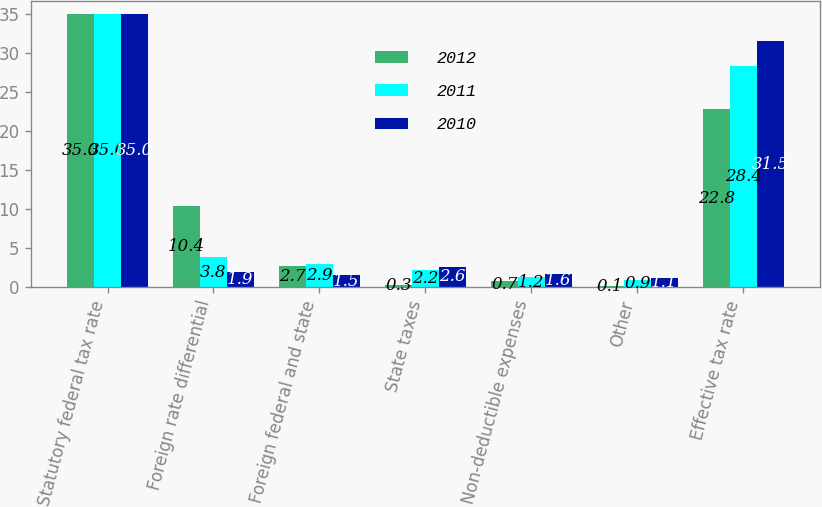<chart> <loc_0><loc_0><loc_500><loc_500><stacked_bar_chart><ecel><fcel>Statutory federal tax rate<fcel>Foreign rate differential<fcel>Foreign federal and state<fcel>State taxes<fcel>Non-deductible expenses<fcel>Other<fcel>Effective tax rate<nl><fcel>2012<fcel>35<fcel>10.4<fcel>2.7<fcel>0.3<fcel>0.7<fcel>0.1<fcel>22.8<nl><fcel>2011<fcel>35<fcel>3.8<fcel>2.9<fcel>2.2<fcel>1.2<fcel>0.9<fcel>28.4<nl><fcel>2010<fcel>35<fcel>1.9<fcel>1.5<fcel>2.6<fcel>1.6<fcel>1.1<fcel>31.5<nl></chart> 